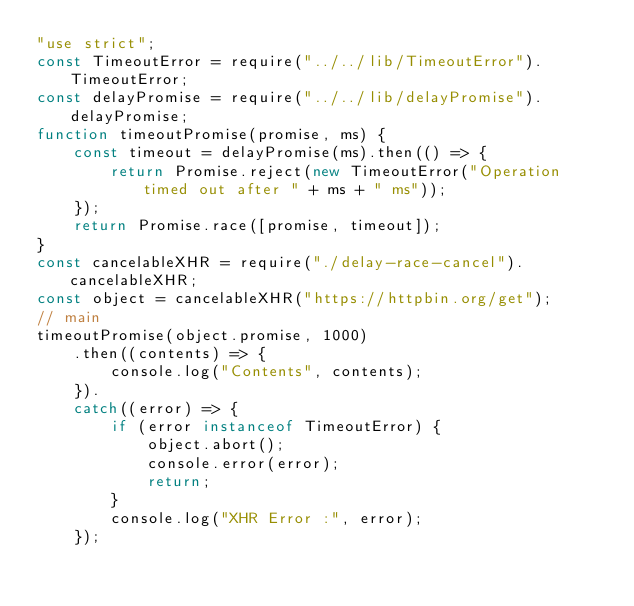Convert code to text. <code><loc_0><loc_0><loc_500><loc_500><_JavaScript_>"use strict";
const TimeoutError = require("../../lib/TimeoutError").TimeoutError;
const delayPromise = require("../../lib/delayPromise").delayPromise;
function timeoutPromise(promise, ms) {
    const timeout = delayPromise(ms).then(() => {
        return Promise.reject(new TimeoutError("Operation timed out after " + ms + " ms"));
    });
    return Promise.race([promise, timeout]);
}
const cancelableXHR = require("./delay-race-cancel").cancelableXHR;
const object = cancelableXHR("https://httpbin.org/get");
// main
timeoutPromise(object.promise, 1000)
    .then((contents) => {
        console.log("Contents", contents);
    }).
    catch((error) => {
        if (error instanceof TimeoutError) {
            object.abort();
            console.error(error);
            return;
        }
        console.log("XHR Error :", error);
    });
</code> 